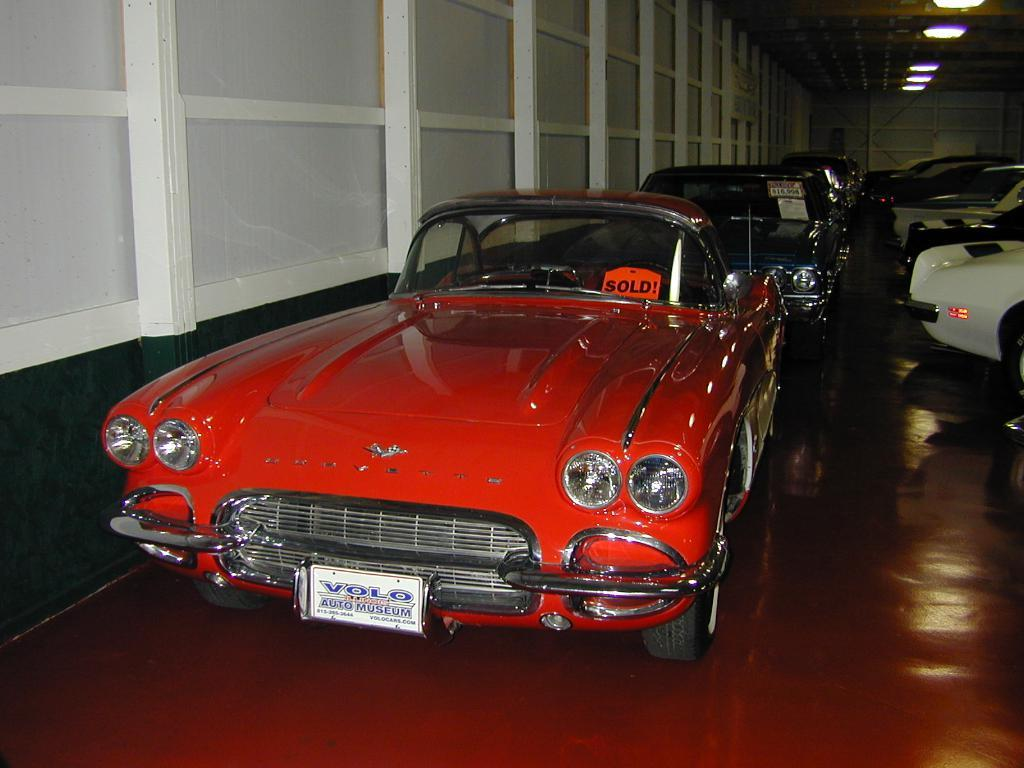What is the main subject in the center of the image? There are different color cars in the center of the image. What is the status of the cars? The cars have "sold" boards on them. What can be seen in the background of the image? There is a wall, a roof, and lights visible in the background of the image. What type of cart is being used to transport the cars in the image? There is no cart present in the image; the cars are stationary with "sold" boards on them. 